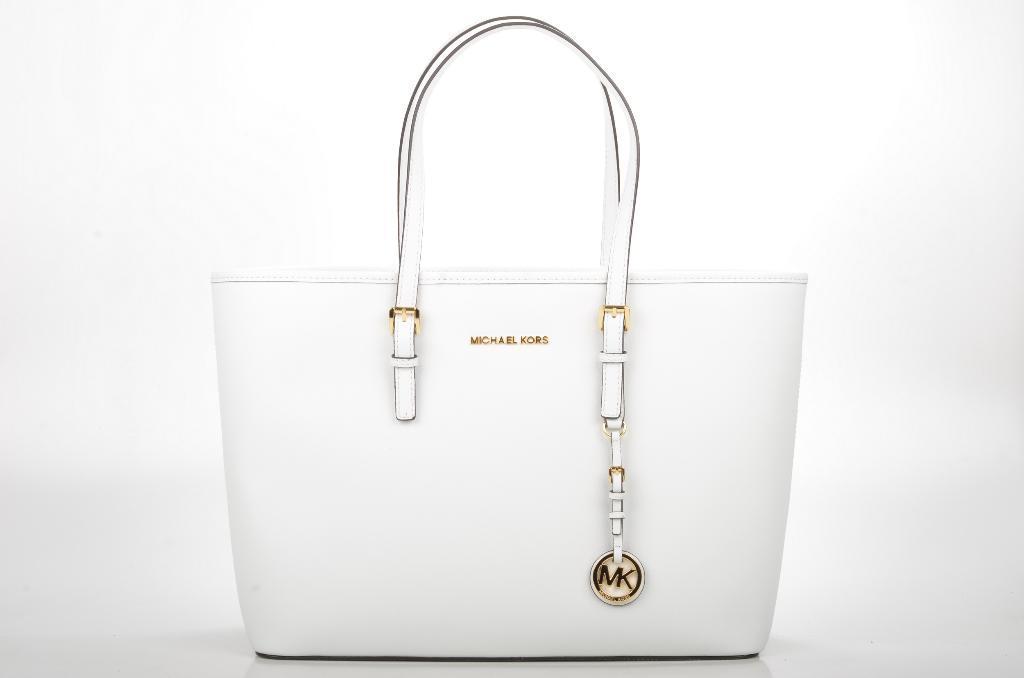In one or two sentences, can you explain what this image depicts? This is a handbag and it is in white color. 